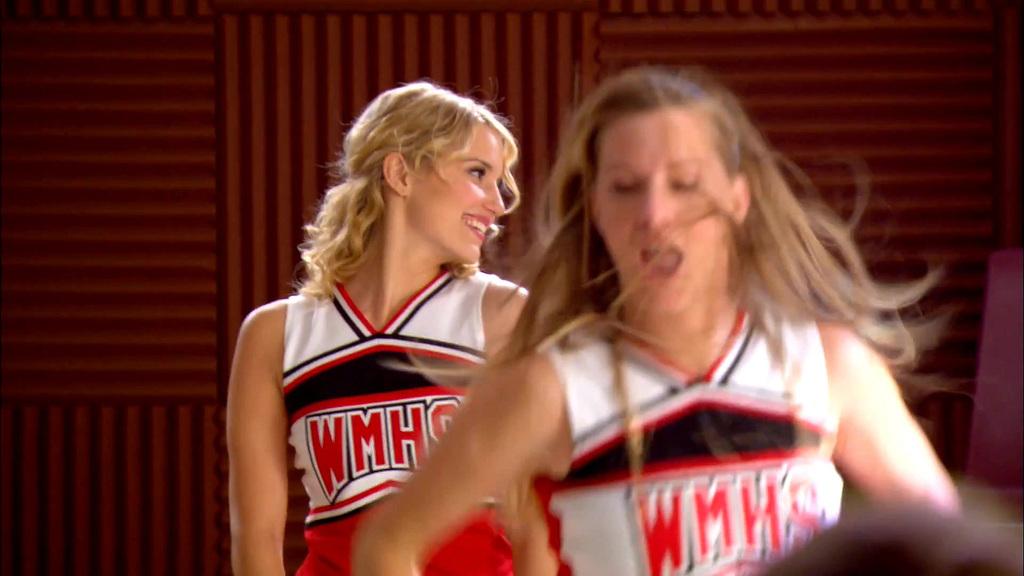What are the initials of the cheerleaders' team?
Your answer should be very brief. Wmhs. What color are the letters on the uniforms?
Offer a very short reply. Red. 